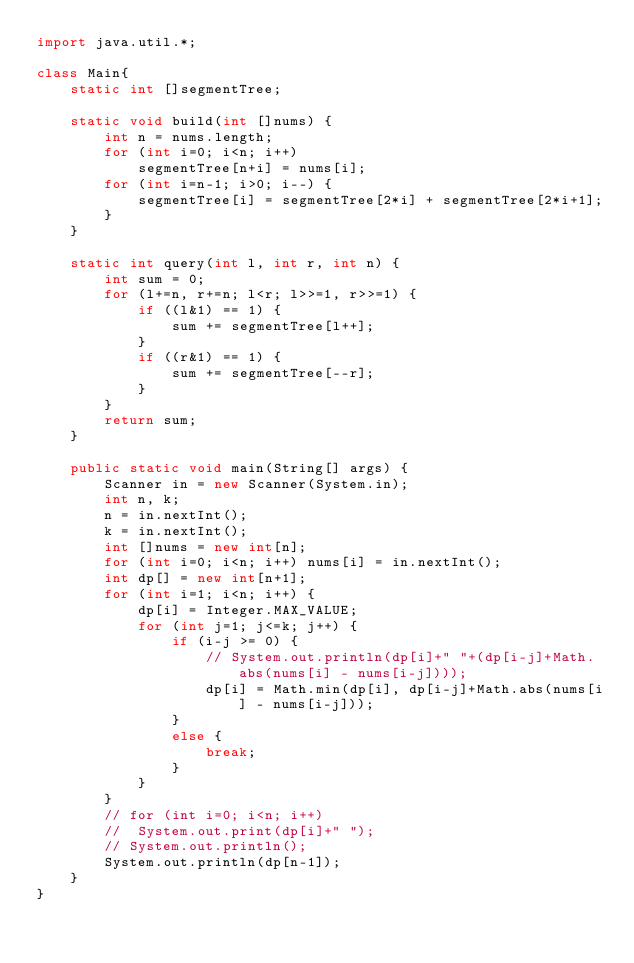<code> <loc_0><loc_0><loc_500><loc_500><_Java_>import java.util.*;

class Main{
	static int []segmentTree;

	static void build(int []nums) {
		int n = nums.length;
		for (int i=0; i<n; i++)
			segmentTree[n+i] = nums[i];
		for (int i=n-1; i>0; i--) {
			segmentTree[i] = segmentTree[2*i] + segmentTree[2*i+1];
		}
	}

	static int query(int l, int r, int n) {
		int sum = 0;
		for (l+=n, r+=n; l<r; l>>=1, r>>=1) {
			if ((l&1) == 1) {
				sum += segmentTree[l++];
			}
			if ((r&1) == 1) {
				sum += segmentTree[--r];
			}
		}
		return sum;
	}

	public static void main(String[] args) {
		Scanner in = new Scanner(System.in);
		int n, k;
		n = in.nextInt();
		k = in.nextInt();
		int []nums = new int[n];
		for (int i=0; i<n; i++) nums[i] = in.nextInt();
		int dp[] = new int[n+1];
		for (int i=1; i<n; i++) {
			dp[i] = Integer.MAX_VALUE;
			for (int j=1; j<=k; j++) {
				if (i-j >= 0) {
					// System.out.println(dp[i]+" "+(dp[i-j]+Math.abs(nums[i] - nums[i-j])));
					dp[i] = Math.min(dp[i], dp[i-j]+Math.abs(nums[i] - nums[i-j]));
				}
				else {
					break;
				}
			}
		}
		// for (int i=0; i<n; i++)
		// 	System.out.print(dp[i]+" ");
		// System.out.println();
		System.out.println(dp[n-1]);
	}
}</code> 